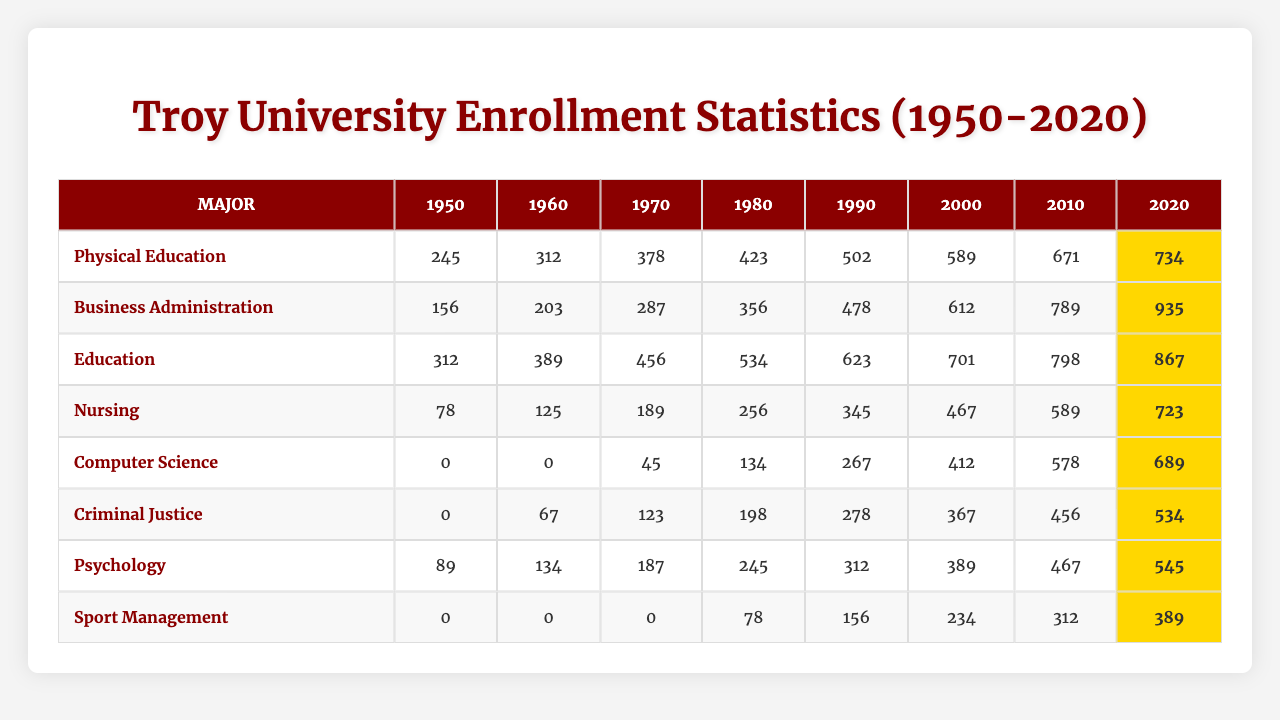What is the highest enrollment for the major "Nursing" during the time frame provided? Looking at the "Nursing" row in the table, the enrollment values are [78, 125, 189, 256, 345, 467, 589, 723]. The highest value in this list is 723, which occurs in the year 2020.
Answer: 723 What was the enrollment for "Computer Science" in 1970? In the "Computer Science" row, the enrollment values are [0, 0, 45, 134, 267, 412, 578, 689]. The value for the year 1970 is 45.
Answer: 45 Which major had the lowest enrollment in 1950? In 1950, the enrollments were: Physical Education (245), Business Administration (156), Education (312), Nursing (78), Computer Science (0), Criminal Justice (0), Psychology (89), and Sport Management (0). The lowest enrollment value is 0, observed in Computer Science, Criminal Justice, and Sport Management.
Answer: Computer Science, Criminal Justice, and Sport Management What is the total enrollment for "Education" from 1950 to 2020? The enrollment values for "Education" are [312, 389, 456, 534, 623, 701, 798, 867]. Adding these values yields 312 + 389 + 456 + 534 + 623 + 701 + 798 + 867 = 4180.
Answer: 4180 How did "Business Administration" enrollment change from 1950 to 2020? The enrollment values for this major are [156, 203, 287, 356, 478, 612, 789, 935]. The enrollment increased from 156 in 1950 to 935 in 2020, showing a positive trend over the years. The difference is 935 - 156 = 779.
Answer: Increased by 779 Is it true that "Sport Management" had any enrollments recorded before 1980? In the enrollment data for "Sport Management," the values are [0, 0, 0, 78, 156, 234, 312, 389]. This showed that there were no enrollments (0) before 1980.
Answer: No Which major showed the highest percent growth in enrollment from 1950 to 2020? To determine the percent growth, we compare the enrollments in 1950 to those in 2020. Calculate percent growth as: ((2020 enrollment - 1950 enrollment) / 1950 enrollment) * 100 for each major. For "Business Administration": ((935 - 156) / 156) * 100 = 497.4%. For "Nursing": ((723 - 78) / 78) * 100 = 925.6%. Calculating for all majors, Nursing shows the highest growth.
Answer: Nursing Which year saw the peak enrollment for "Psychology"? Referring to the "Psychology" row, the enrollment values are [89, 134, 187, 245, 312, 389, 467, 545]. The highest value is 545, which occurs in the year 2020.
Answer: 2020 What was the average enrollment for "Criminal Justice" over the years? The enrollment values are [0, 67, 123, 198, 278, 367, 456, 534]. To find the average, sum these values: 0 + 67 + 123 + 198 + 278 + 367 + 456 + 534 = 2023, then divide by the total number of years (8). Thus, the average is 2023 / 8 = 252.875.
Answer: 252.875 Which major consistently had no enrollments from 1950 to 1960? In the table, both "Computer Science" and "Sport Management" have enrollment values of 0 for 1950 and 1960. Therefore, both consistently had no enrollments during those years.
Answer: Computer Science and Sport Management What is the difference in enrollment for "Physical Education" between 1980 and 2020? The enrollment values for "Physical Education" are [245, 312, 378, 423, 502, 589, 671, 734]. The values for these years are 423 (1980) and 734 (2020). The difference is 734 - 423 = 311.
Answer: 311 